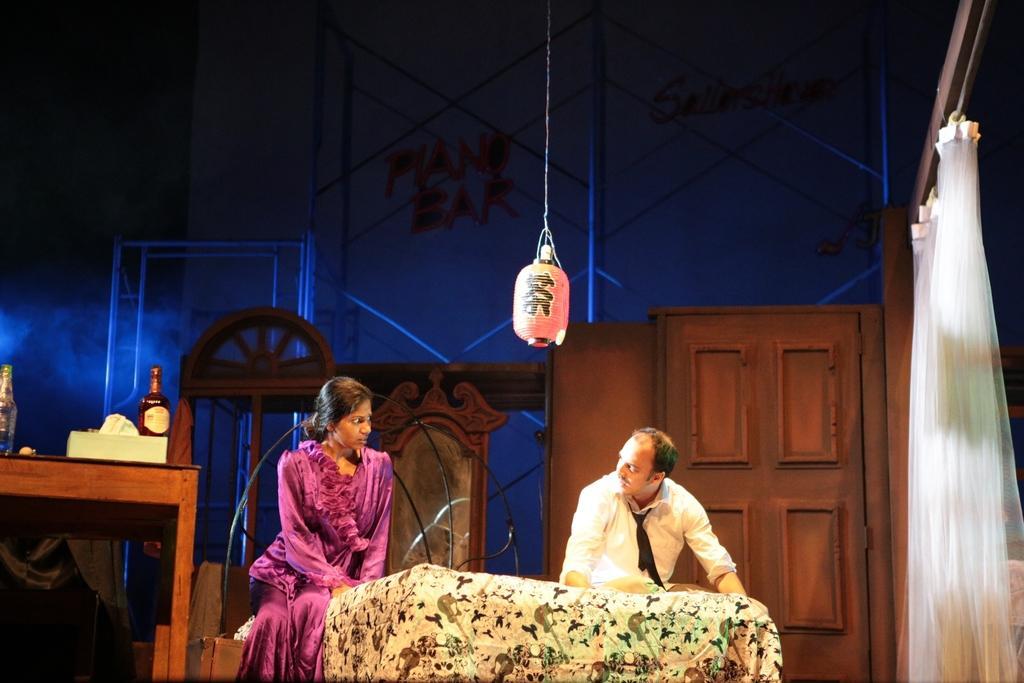Can you describe this image briefly? This is a picture taken on a stage, there are two persons sitting on a bed to the left side of the people there is a table on the table there are tissues and bottles to the right side of the people there is a curtain which is in white color. Behind the people there are wooden door and a wall. On top of them there is a light. 